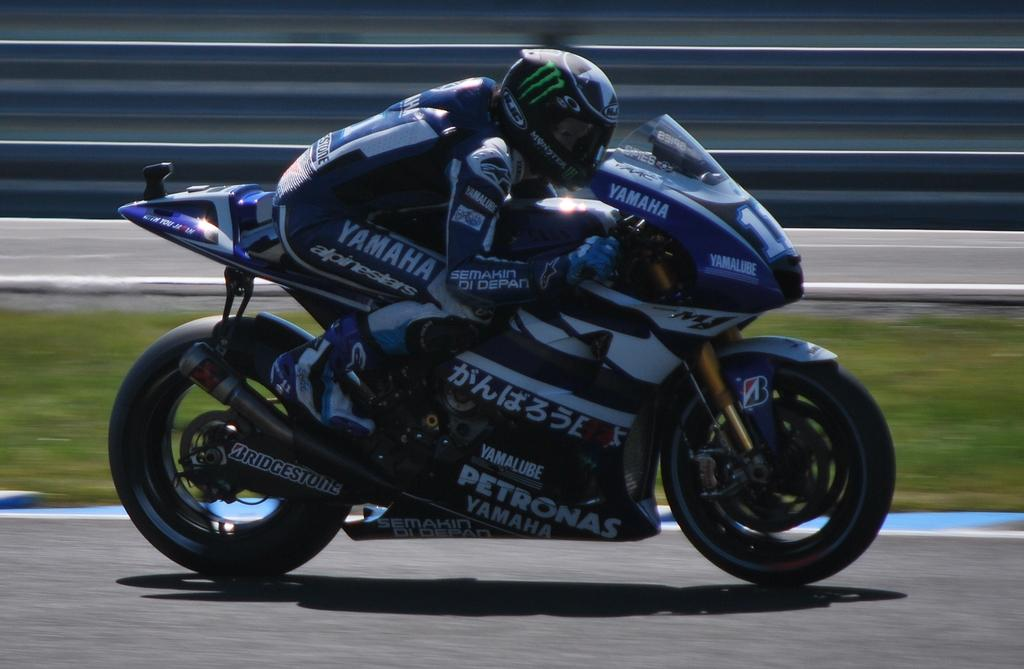What is the person in the image doing? The person is riding a sports bike in the image. What type of surface is the person riding on? The person is on the road in the image. What clothing is the person wearing? The person is wearing sportswear and a helmet in the image. What can be seen beside the road? There is a grass surface beside the road in the image. What is visible behind the grass surface? There is a road visible behind the grass surface in the image. What type of brain can be seen in the image? There is no brain visible in the image; it features a person riding a sports bike on the road. What act is the person performing in the image? The person is riding a sports bike, which is a specific action, but there is no broader "act" being performed in the image. 